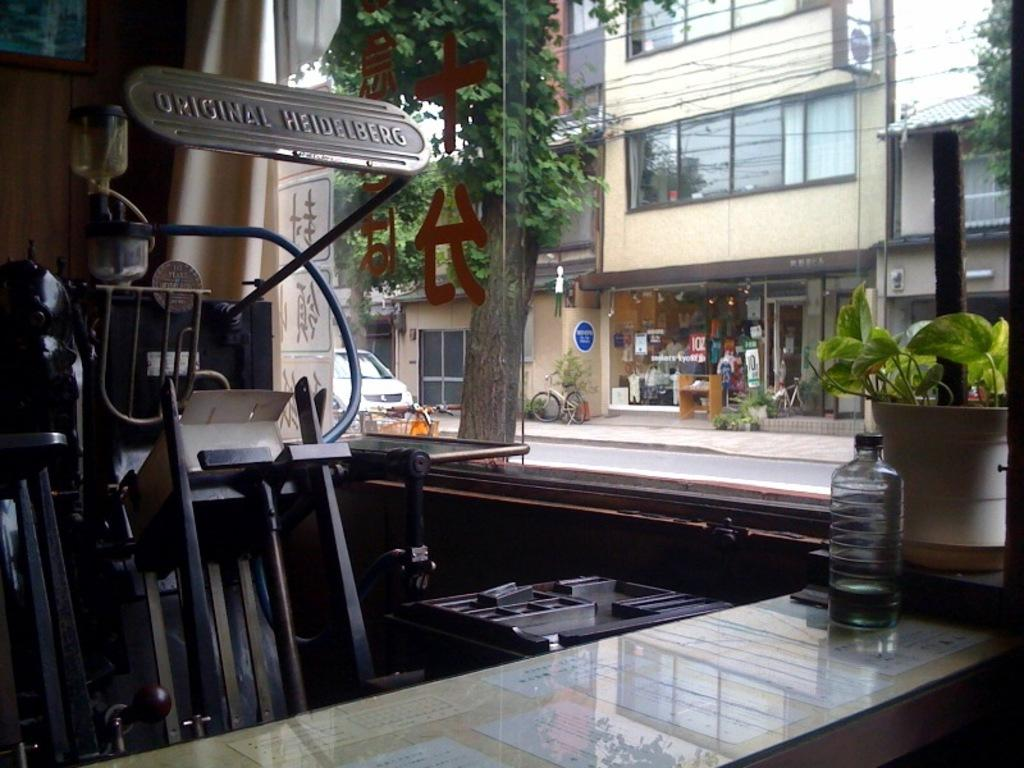<image>
Describe the image concisely. A piece of machinery by a window is labeled Original Heidelberg. 